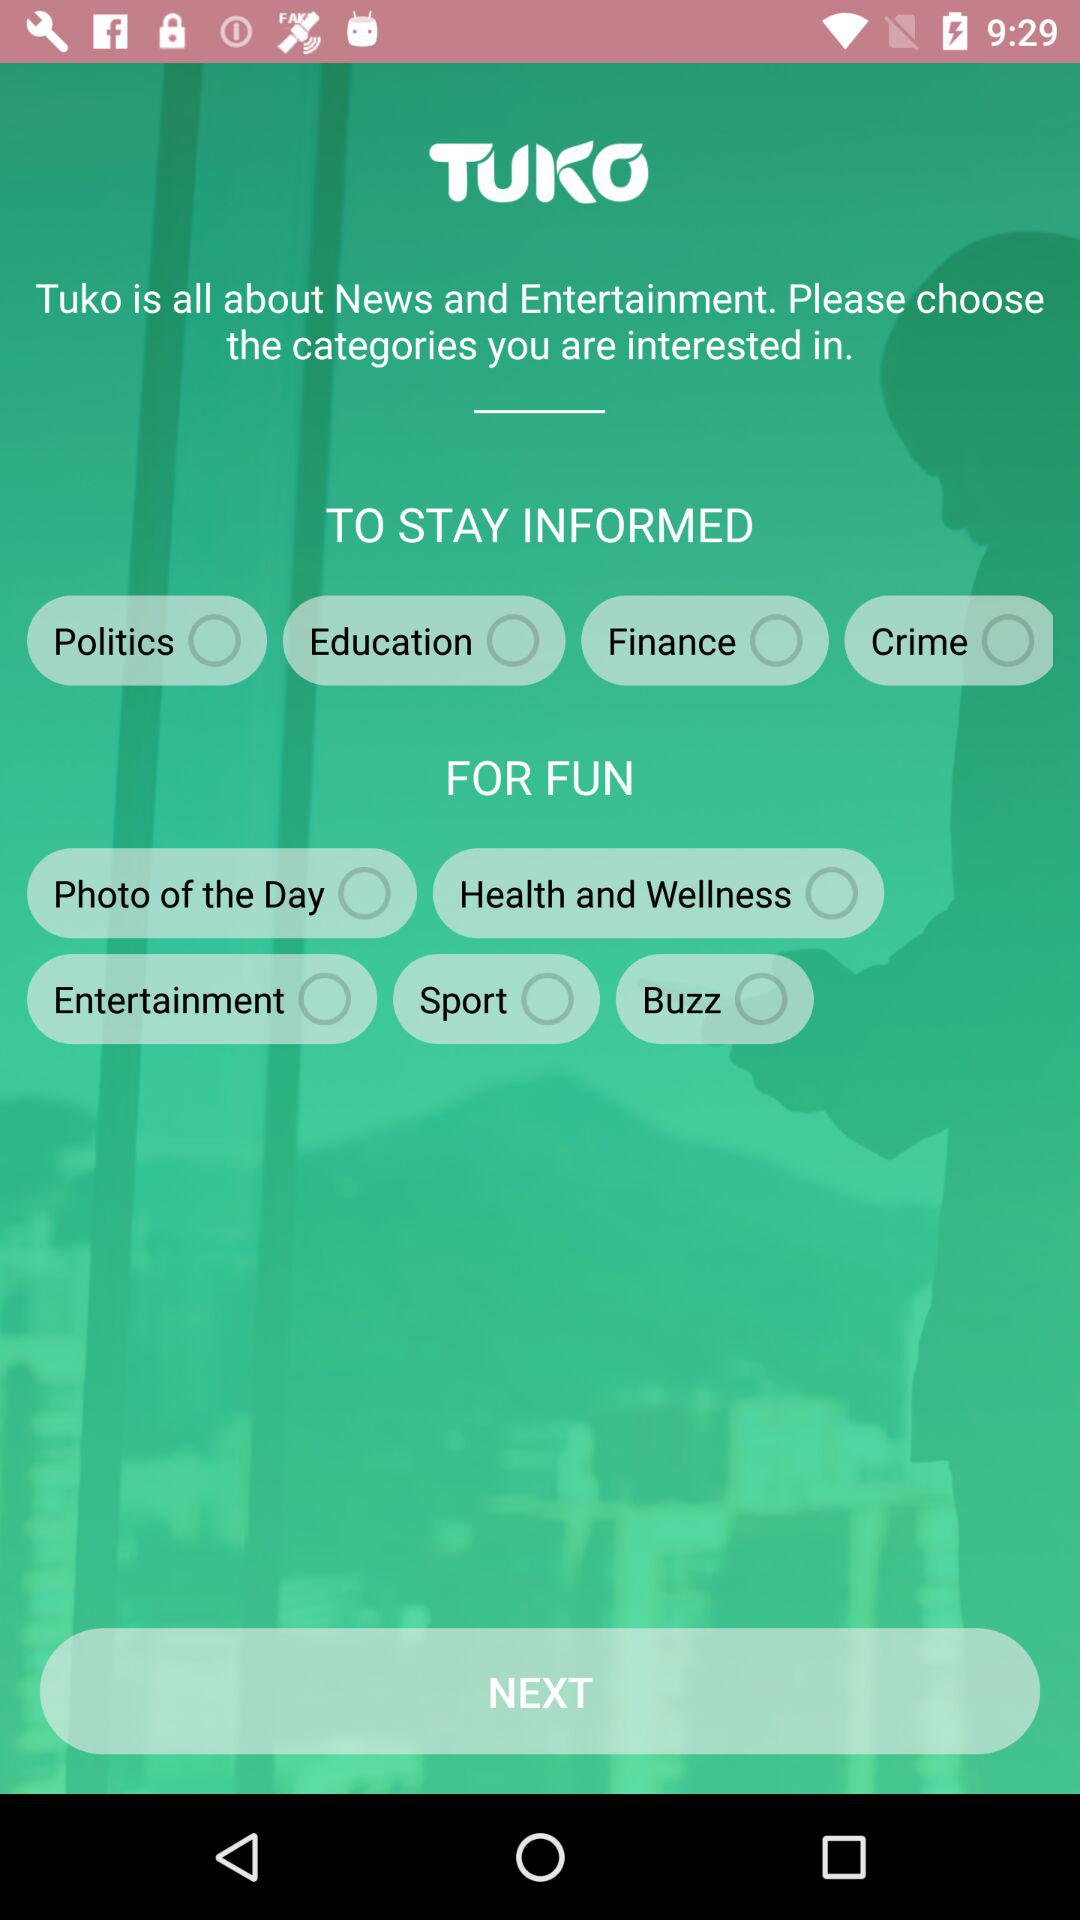How many categories are there for staying informed?
Answer the question using a single word or phrase. 4 